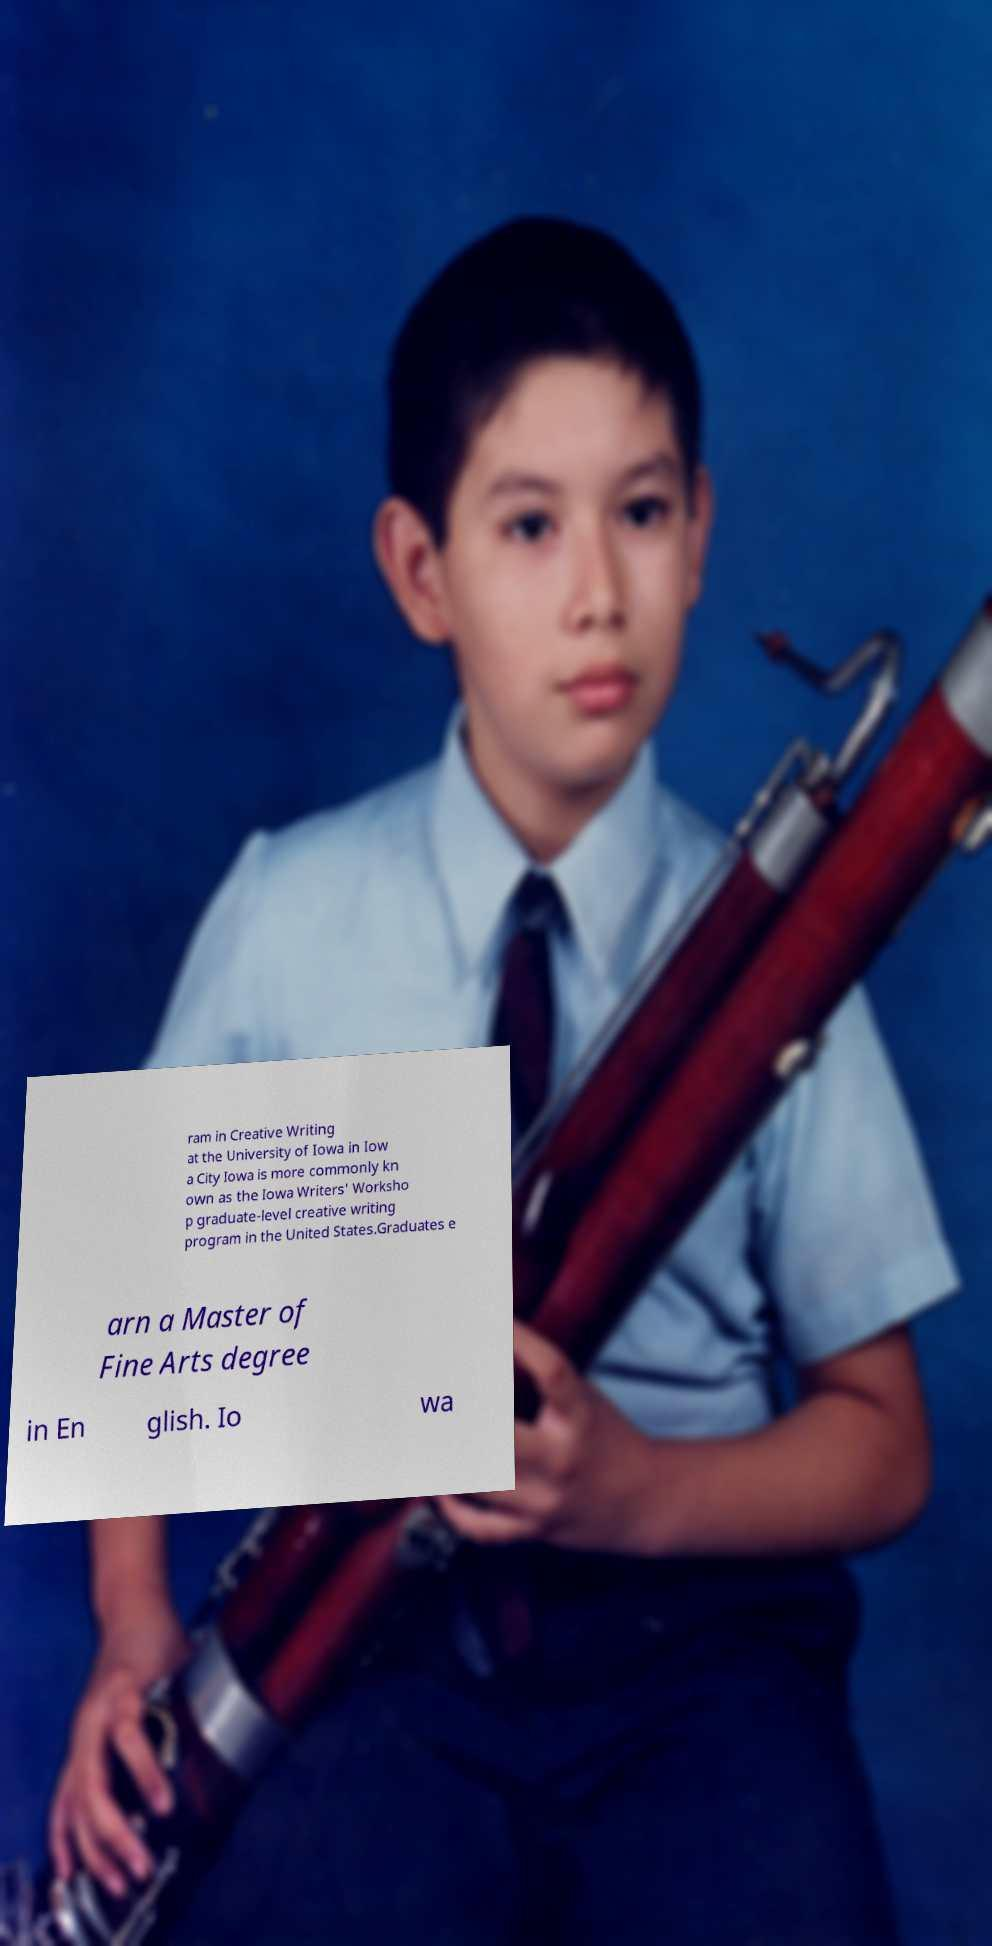Please identify and transcribe the text found in this image. ram in Creative Writing at the University of Iowa in Iow a City Iowa is more commonly kn own as the Iowa Writers' Worksho p graduate-level creative writing program in the United States.Graduates e arn a Master of Fine Arts degree in En glish. Io wa 